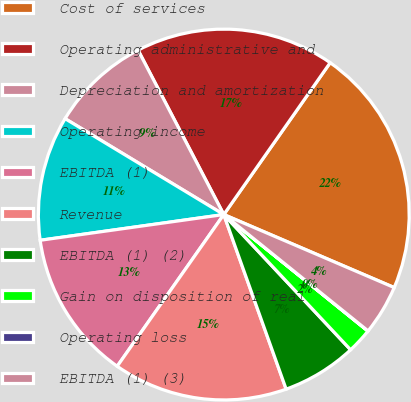<chart> <loc_0><loc_0><loc_500><loc_500><pie_chart><fcel>Cost of services<fcel>Operating administrative and<fcel>Depreciation and amortization<fcel>Operating income<fcel>EBITDA (1)<fcel>Revenue<fcel>EBITDA (1) (2)<fcel>Gain on disposition of real<fcel>Operating loss<fcel>EBITDA (1) (3)<nl><fcel>21.72%<fcel>17.38%<fcel>8.7%<fcel>10.87%<fcel>13.04%<fcel>15.21%<fcel>6.53%<fcel>2.19%<fcel>0.02%<fcel>4.36%<nl></chart> 